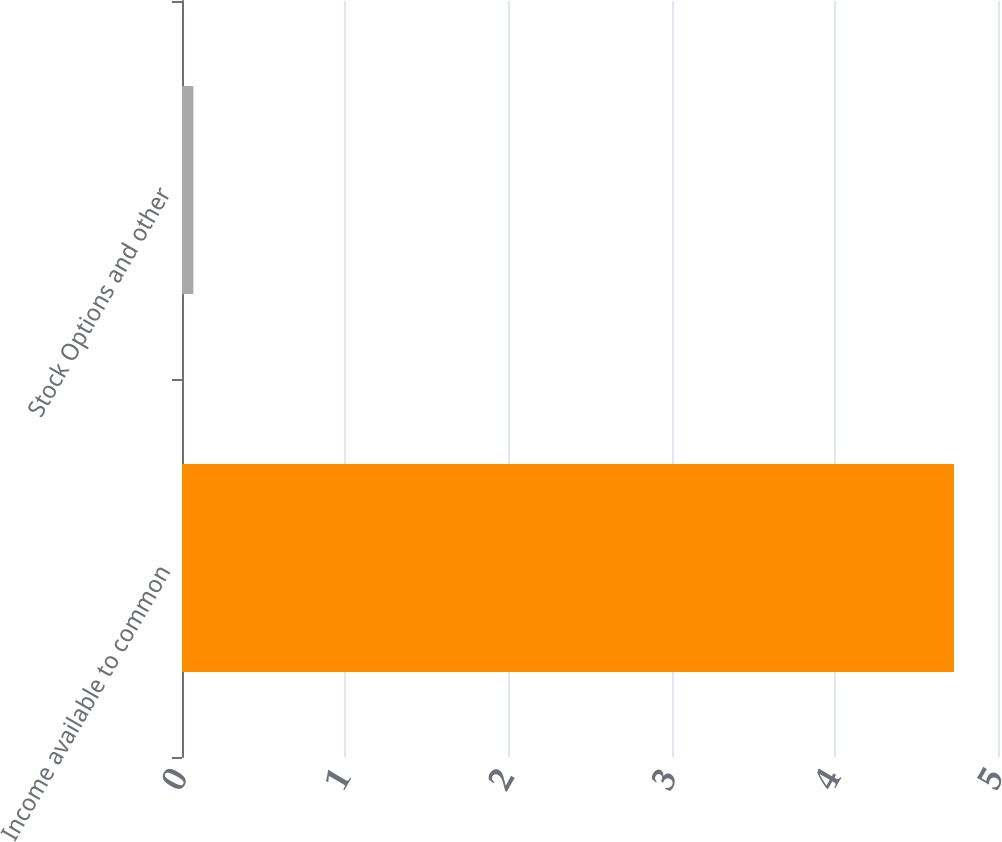<chart> <loc_0><loc_0><loc_500><loc_500><bar_chart><fcel>Income available to common<fcel>Stock Options and other<nl><fcel>4.73<fcel>0.07<nl></chart> 